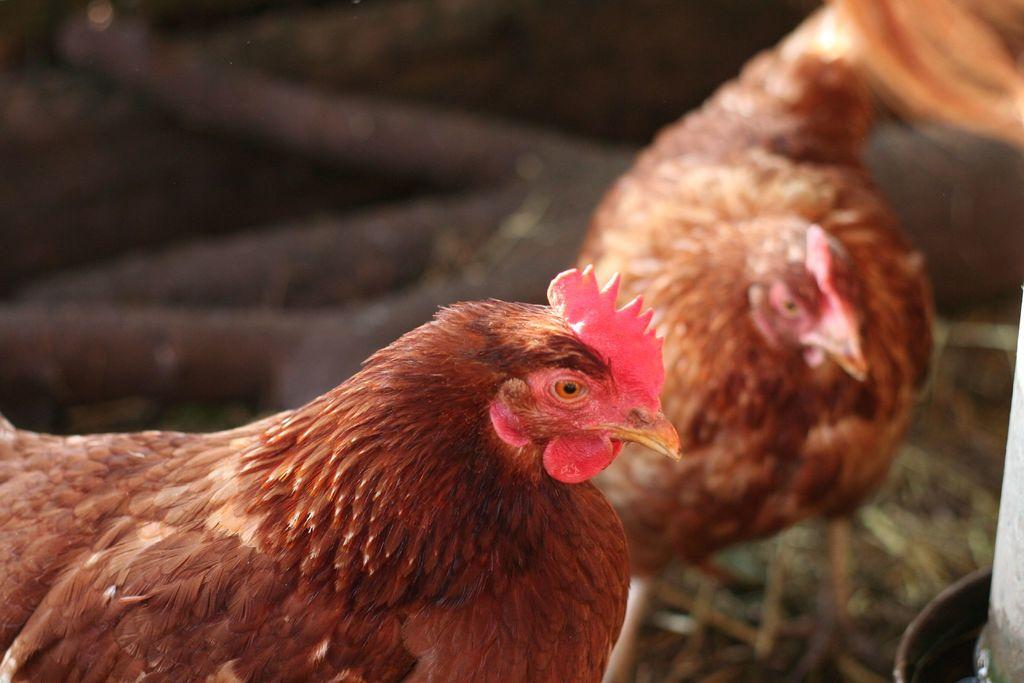What animals are present in the image? There are two hens in the image. Can you describe any other objects or structures in the image? Yes, there is a pole in the right side corner of the image. What type of condition is the pole in the image? The pole does not have a specific condition mentioned in the image; it is simply a pole. How many cats can be seen interacting with the hens in the image? There are no cats present in the image. Are there any cherries visible in the image? There is no mention of cherries in the image. 